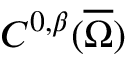Convert formula to latex. <formula><loc_0><loc_0><loc_500><loc_500>C ^ { 0 , \beta } ( { \overline { \Omega } } )</formula> 